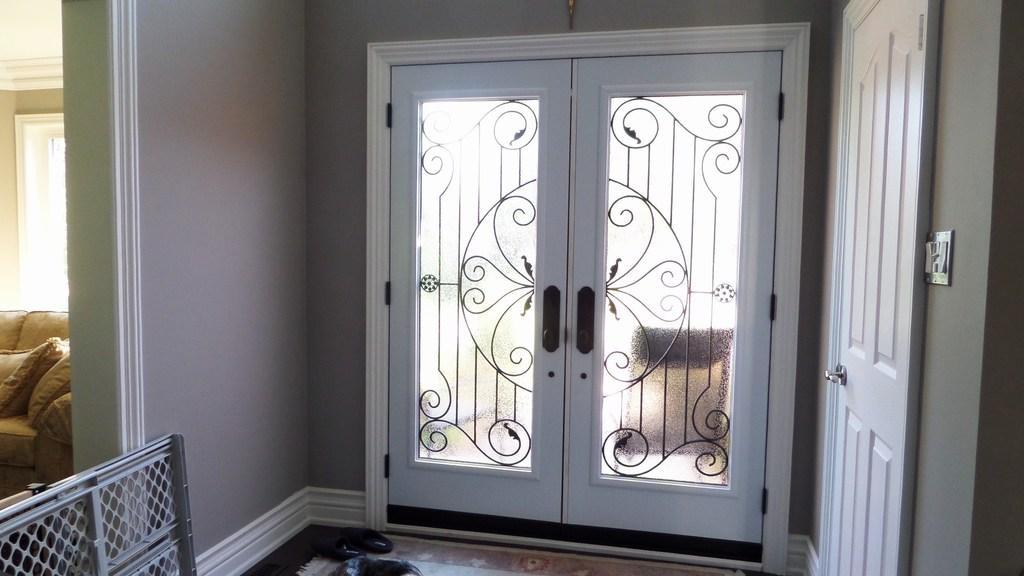In one or two sentences, can you explain what this image depicts? In the image there is a door in the front on the wall and another door on right side, this is clicked inside a room, on the left side there is a sofa visible. 